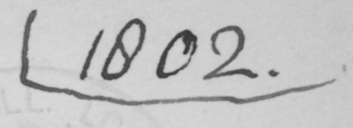Please transcribe the handwritten text in this image. 1802 . 